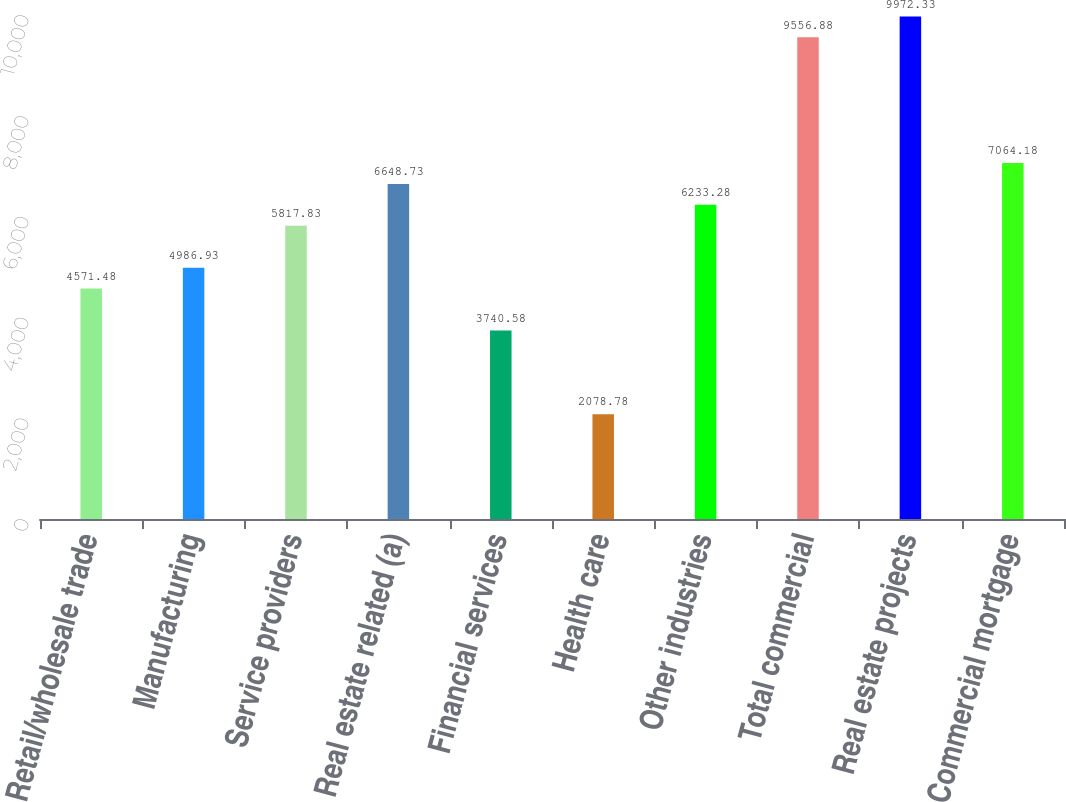Convert chart to OTSL. <chart><loc_0><loc_0><loc_500><loc_500><bar_chart><fcel>Retail/wholesale trade<fcel>Manufacturing<fcel>Service providers<fcel>Real estate related (a)<fcel>Financial services<fcel>Health care<fcel>Other industries<fcel>Total commercial<fcel>Real estate projects<fcel>Commercial mortgage<nl><fcel>4571.48<fcel>4986.93<fcel>5817.83<fcel>6648.73<fcel>3740.58<fcel>2078.78<fcel>6233.28<fcel>9556.88<fcel>9972.33<fcel>7064.18<nl></chart> 